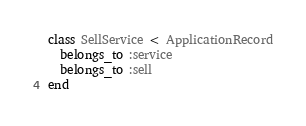Convert code to text. <code><loc_0><loc_0><loc_500><loc_500><_Ruby_>class SellService < ApplicationRecord
  belongs_to :service
  belongs_to :sell
end
</code> 